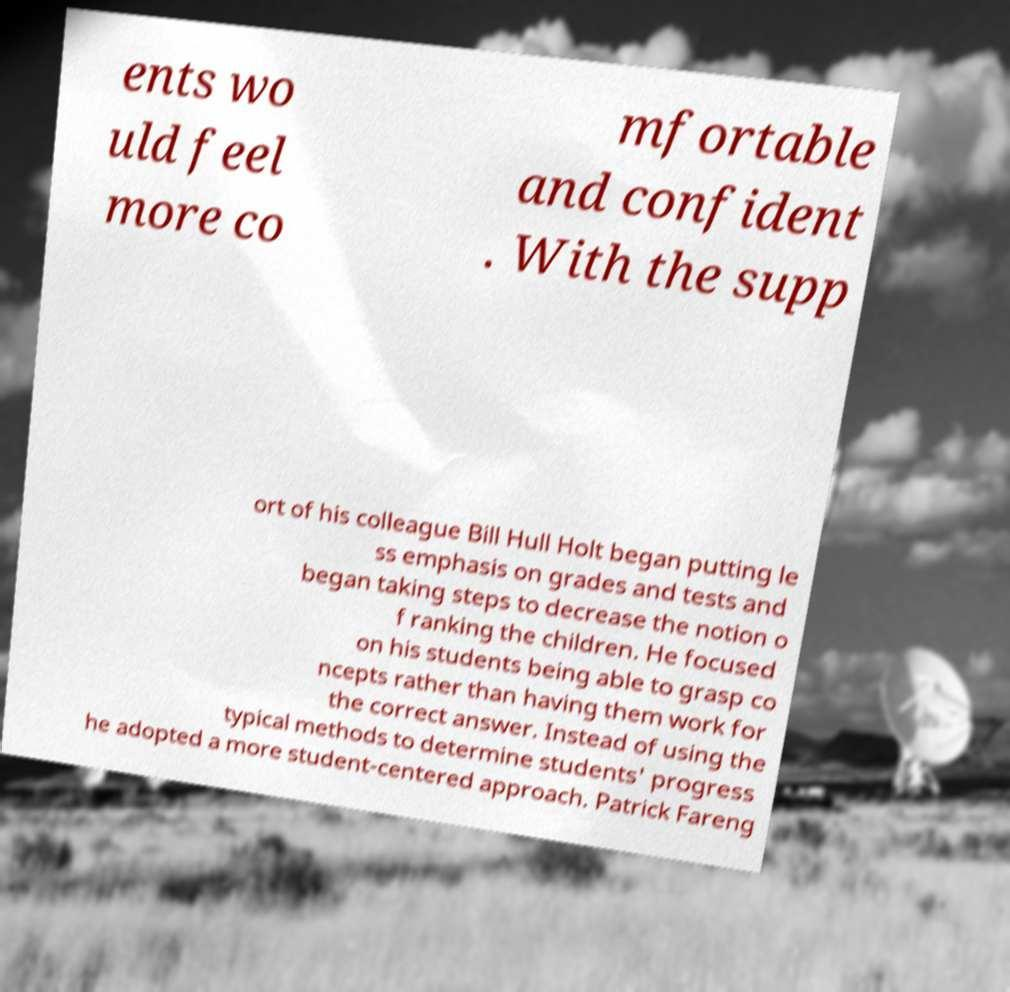There's text embedded in this image that I need extracted. Can you transcribe it verbatim? ents wo uld feel more co mfortable and confident . With the supp ort of his colleague Bill Hull Holt began putting le ss emphasis on grades and tests and began taking steps to decrease the notion o f ranking the children. He focused on his students being able to grasp co ncepts rather than having them work for the correct answer. Instead of using the typical methods to determine students' progress he adopted a more student-centered approach. Patrick Fareng 